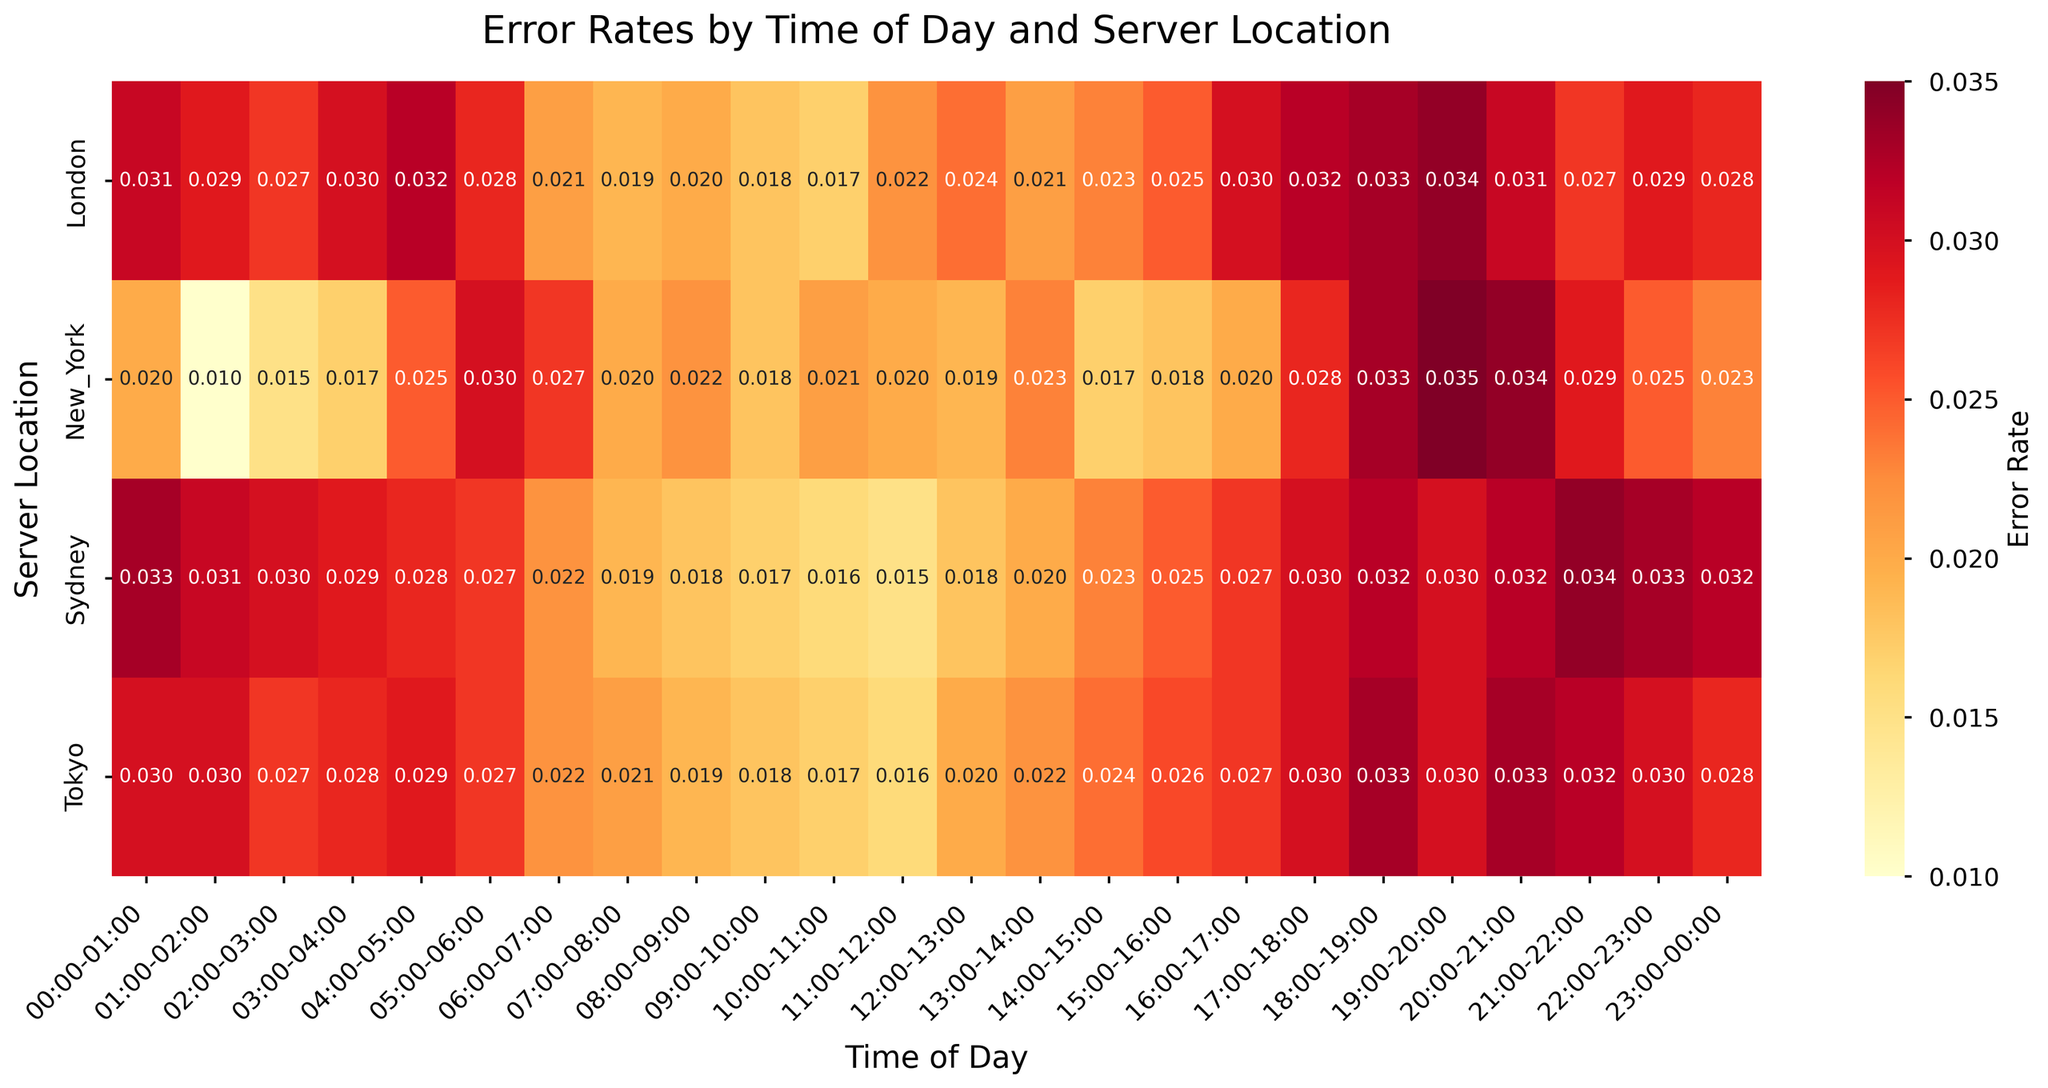What is the title of the heatmap? The title of the heatmap is located at the top of the figure, usually in a larger font size than the rest of the text.
Answer: Error Rates by Time of Day and Server Location Which server location has the highest error rate at 18:00-19:00? By looking at the heatmap, locate the column for "18:00-19:00" and find the highest value among all server locations in that column.
Answer: New_York What is the average error rate for New York between 00:00 and 06:00? First, extract the error rates for New York for the given time range: 00:00-00:01 (0.02), 01:00-02:00 (0.01), 02:00-03:00 (0.015), 03:00-04:00 (0.017), 04:00-05:00 (0.025), and 05:00-06:00 (0.03). Sum these values and divide by the number of data points (6).
Answer: (0.02 + 0.01 + 0.015 + 0.017 + 0.025 + 0.03) / 6 = 0.0195 How does the error rate in London at 10:00-11:00 compare to Sydney at the same time? Locate the error rate for London at 10:00-11:00 and then locate Sydney's error rate at the same time. Compare the two values.
Answer: London's rate is 0.017, which is higher than Sydney's rate of 0.016 Which time of day generally shows the highest error rates across all server locations? Review the values for each time slot across all server locations and identify the time slot with the highest cumulative error rates.
Answer: 19:00-20:00 What is the median error rate for Tokyo from 12:00 to 18:00? Extract the error rates for Tokyo from 12:00 to 18:00: 12:00-13:00 (0.02), 13:00-14:00 (0.022), 14:00-15:00 (0.024), 15:00-16:00 (0.026), 16:00-17:00 (0.027), 17:00-18:00 (0.03). Sort these values and find the median.
Answer: 0.024 Are there any time periods when all server locations experience a similar error rate? Examine each time period across all server locations to see if any show similar or almost equal error rates.
Answer: 09:00-10:00 has rates of New_York (0.018), London (0.018), Tokyo (0.018), and Sydney (0.017), showing similarity Which location has the most consistent error rates throughout the day? Review the variability in the error rates for each location throughout the day. Measure consistency by the range or variance in error rates.
Answer: Tokyo 